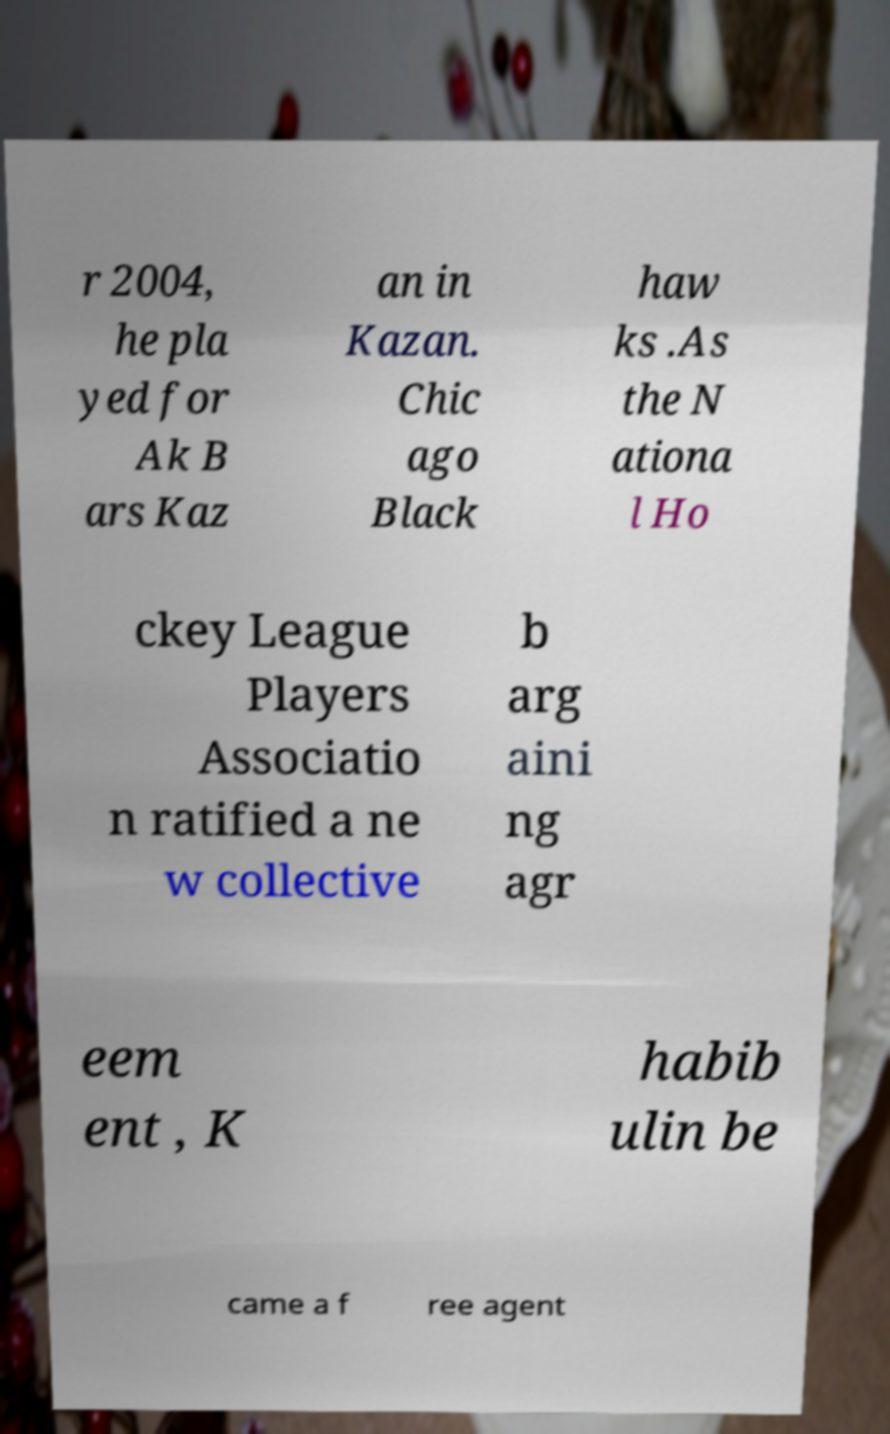For documentation purposes, I need the text within this image transcribed. Could you provide that? r 2004, he pla yed for Ak B ars Kaz an in Kazan. Chic ago Black haw ks .As the N ationa l Ho ckey League Players Associatio n ratified a ne w collective b arg aini ng agr eem ent , K habib ulin be came a f ree agent 